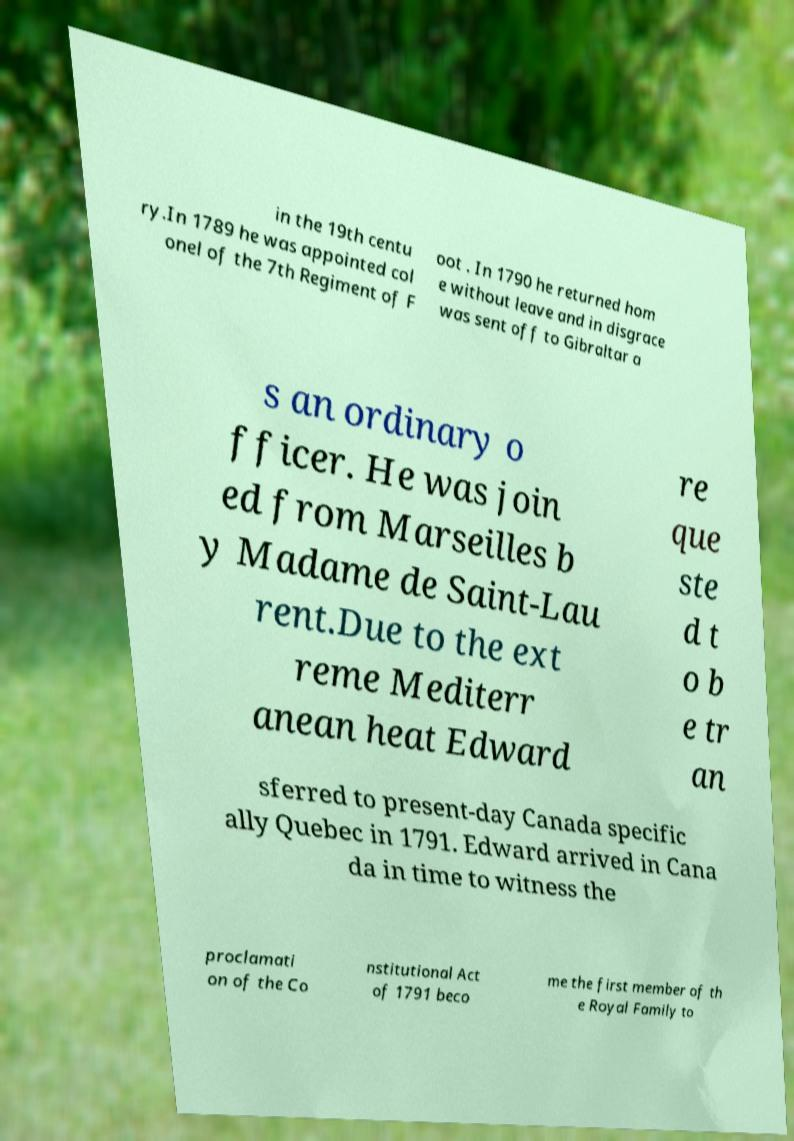What messages or text are displayed in this image? I need them in a readable, typed format. in the 19th centu ry.In 1789 he was appointed col onel of the 7th Regiment of F oot . In 1790 he returned hom e without leave and in disgrace was sent off to Gibraltar a s an ordinary o fficer. He was join ed from Marseilles b y Madame de Saint-Lau rent.Due to the ext reme Mediterr anean heat Edward re que ste d t o b e tr an sferred to present-day Canada specific ally Quebec in 1791. Edward arrived in Cana da in time to witness the proclamati on of the Co nstitutional Act of 1791 beco me the first member of th e Royal Family to 